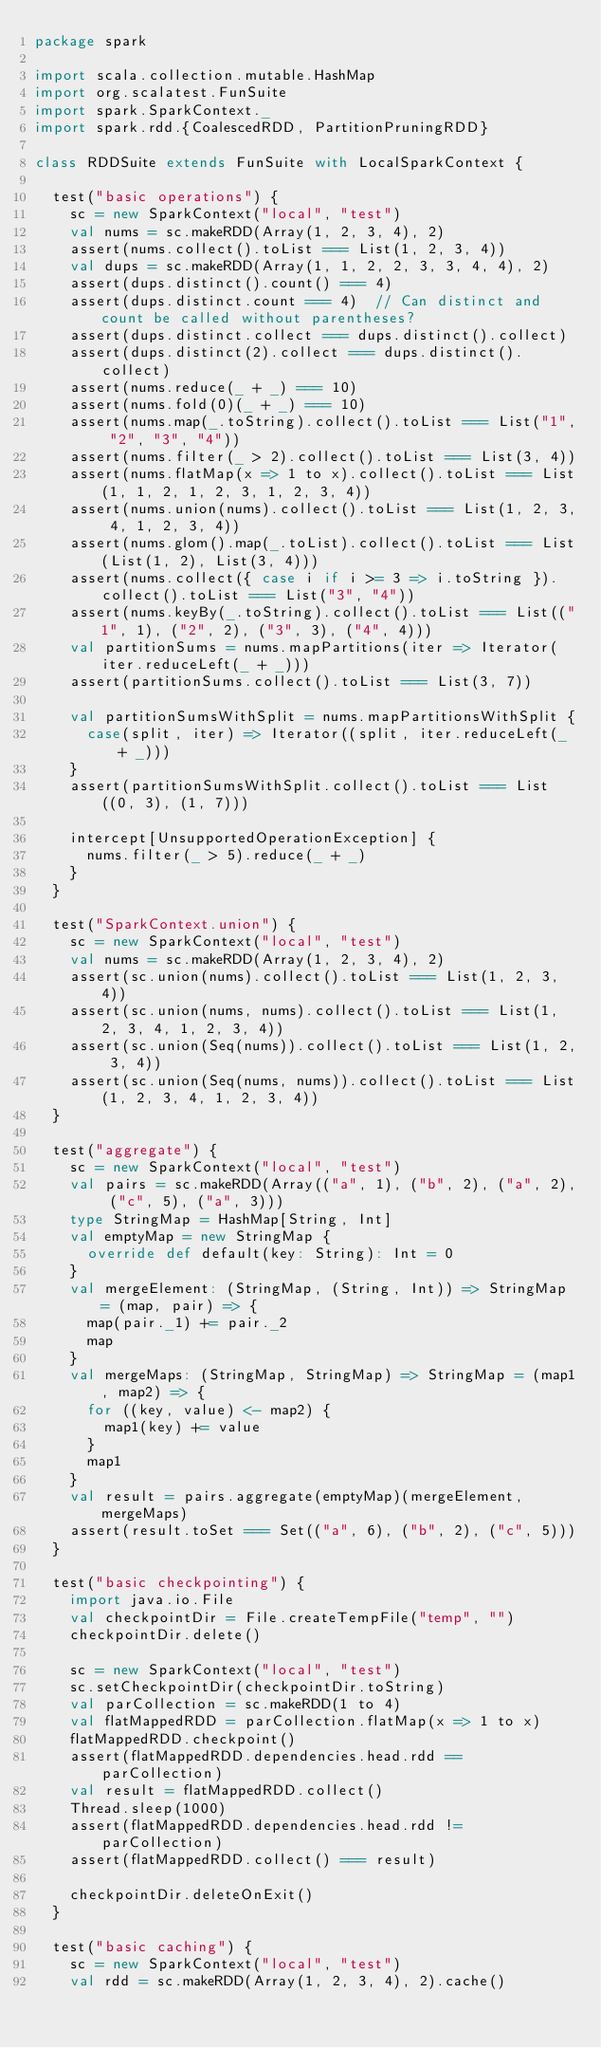Convert code to text. <code><loc_0><loc_0><loc_500><loc_500><_Scala_>package spark

import scala.collection.mutable.HashMap
import org.scalatest.FunSuite
import spark.SparkContext._
import spark.rdd.{CoalescedRDD, PartitionPruningRDD}

class RDDSuite extends FunSuite with LocalSparkContext {

  test("basic operations") {
    sc = new SparkContext("local", "test")
    val nums = sc.makeRDD(Array(1, 2, 3, 4), 2)
    assert(nums.collect().toList === List(1, 2, 3, 4))
    val dups = sc.makeRDD(Array(1, 1, 2, 2, 3, 3, 4, 4), 2)
    assert(dups.distinct().count() === 4)
    assert(dups.distinct.count === 4)  // Can distinct and count be called without parentheses?
    assert(dups.distinct.collect === dups.distinct().collect)
    assert(dups.distinct(2).collect === dups.distinct().collect)
    assert(nums.reduce(_ + _) === 10)
    assert(nums.fold(0)(_ + _) === 10)
    assert(nums.map(_.toString).collect().toList === List("1", "2", "3", "4"))
    assert(nums.filter(_ > 2).collect().toList === List(3, 4))
    assert(nums.flatMap(x => 1 to x).collect().toList === List(1, 1, 2, 1, 2, 3, 1, 2, 3, 4))
    assert(nums.union(nums).collect().toList === List(1, 2, 3, 4, 1, 2, 3, 4))
    assert(nums.glom().map(_.toList).collect().toList === List(List(1, 2), List(3, 4)))
    assert(nums.collect({ case i if i >= 3 => i.toString }).collect().toList === List("3", "4"))
    assert(nums.keyBy(_.toString).collect().toList === List(("1", 1), ("2", 2), ("3", 3), ("4", 4)))
    val partitionSums = nums.mapPartitions(iter => Iterator(iter.reduceLeft(_ + _)))
    assert(partitionSums.collect().toList === List(3, 7))

    val partitionSumsWithSplit = nums.mapPartitionsWithSplit {
      case(split, iter) => Iterator((split, iter.reduceLeft(_ + _)))
    }
    assert(partitionSumsWithSplit.collect().toList === List((0, 3), (1, 7)))

    intercept[UnsupportedOperationException] {
      nums.filter(_ > 5).reduce(_ + _)
    }
  }

  test("SparkContext.union") {
    sc = new SparkContext("local", "test")
    val nums = sc.makeRDD(Array(1, 2, 3, 4), 2)
    assert(sc.union(nums).collect().toList === List(1, 2, 3, 4))
    assert(sc.union(nums, nums).collect().toList === List(1, 2, 3, 4, 1, 2, 3, 4))
    assert(sc.union(Seq(nums)).collect().toList === List(1, 2, 3, 4))
    assert(sc.union(Seq(nums, nums)).collect().toList === List(1, 2, 3, 4, 1, 2, 3, 4))
  }

  test("aggregate") {
    sc = new SparkContext("local", "test")
    val pairs = sc.makeRDD(Array(("a", 1), ("b", 2), ("a", 2), ("c", 5), ("a", 3)))
    type StringMap = HashMap[String, Int]
    val emptyMap = new StringMap {
      override def default(key: String): Int = 0
    }
    val mergeElement: (StringMap, (String, Int)) => StringMap = (map, pair) => {
      map(pair._1) += pair._2
      map
    }
    val mergeMaps: (StringMap, StringMap) => StringMap = (map1, map2) => {
      for ((key, value) <- map2) {
        map1(key) += value
      }
      map1
    }
    val result = pairs.aggregate(emptyMap)(mergeElement, mergeMaps)
    assert(result.toSet === Set(("a", 6), ("b", 2), ("c", 5)))
  }

  test("basic checkpointing") {
    import java.io.File
    val checkpointDir = File.createTempFile("temp", "")
    checkpointDir.delete()

    sc = new SparkContext("local", "test")
    sc.setCheckpointDir(checkpointDir.toString)
    val parCollection = sc.makeRDD(1 to 4)
    val flatMappedRDD = parCollection.flatMap(x => 1 to x)
    flatMappedRDD.checkpoint()
    assert(flatMappedRDD.dependencies.head.rdd == parCollection)
    val result = flatMappedRDD.collect()
    Thread.sleep(1000)
    assert(flatMappedRDD.dependencies.head.rdd != parCollection)
    assert(flatMappedRDD.collect() === result)

    checkpointDir.deleteOnExit()
  }

  test("basic caching") {
    sc = new SparkContext("local", "test")
    val rdd = sc.makeRDD(Array(1, 2, 3, 4), 2).cache()</code> 